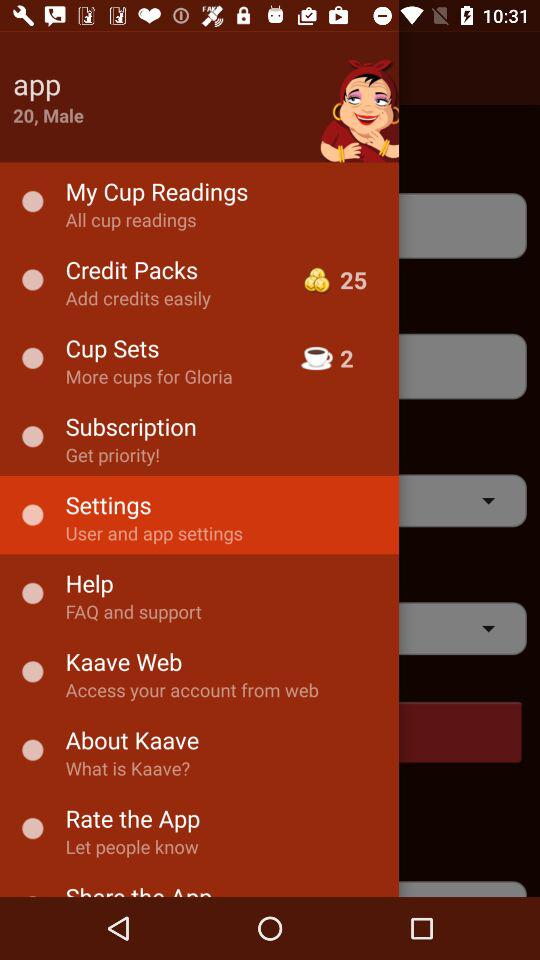What is the count of items in "Cup Sets"? The count of items in "Cup Sets" is 2. 